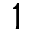Convert formula to latex. <formula><loc_0><loc_0><loc_500><loc_500>1</formula> 